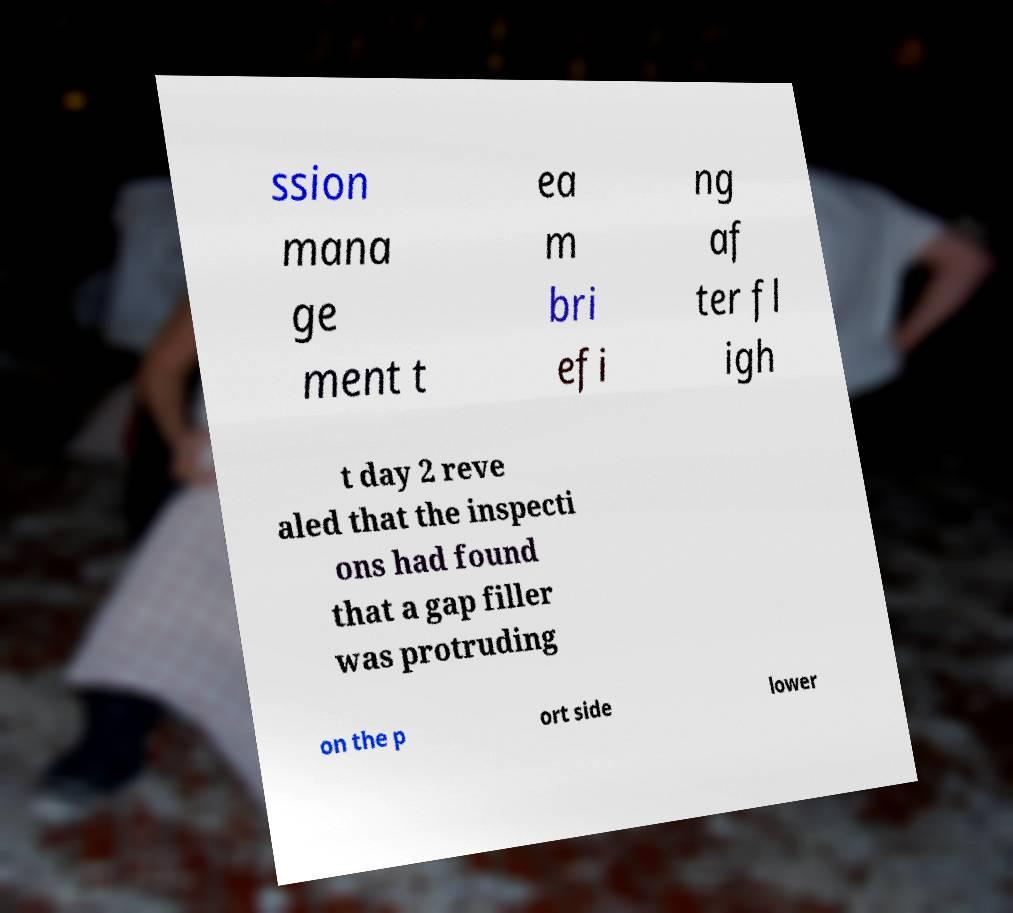I need the written content from this picture converted into text. Can you do that? ssion mana ge ment t ea m bri efi ng af ter fl igh t day 2 reve aled that the inspecti ons had found that a gap filler was protruding on the p ort side lower 